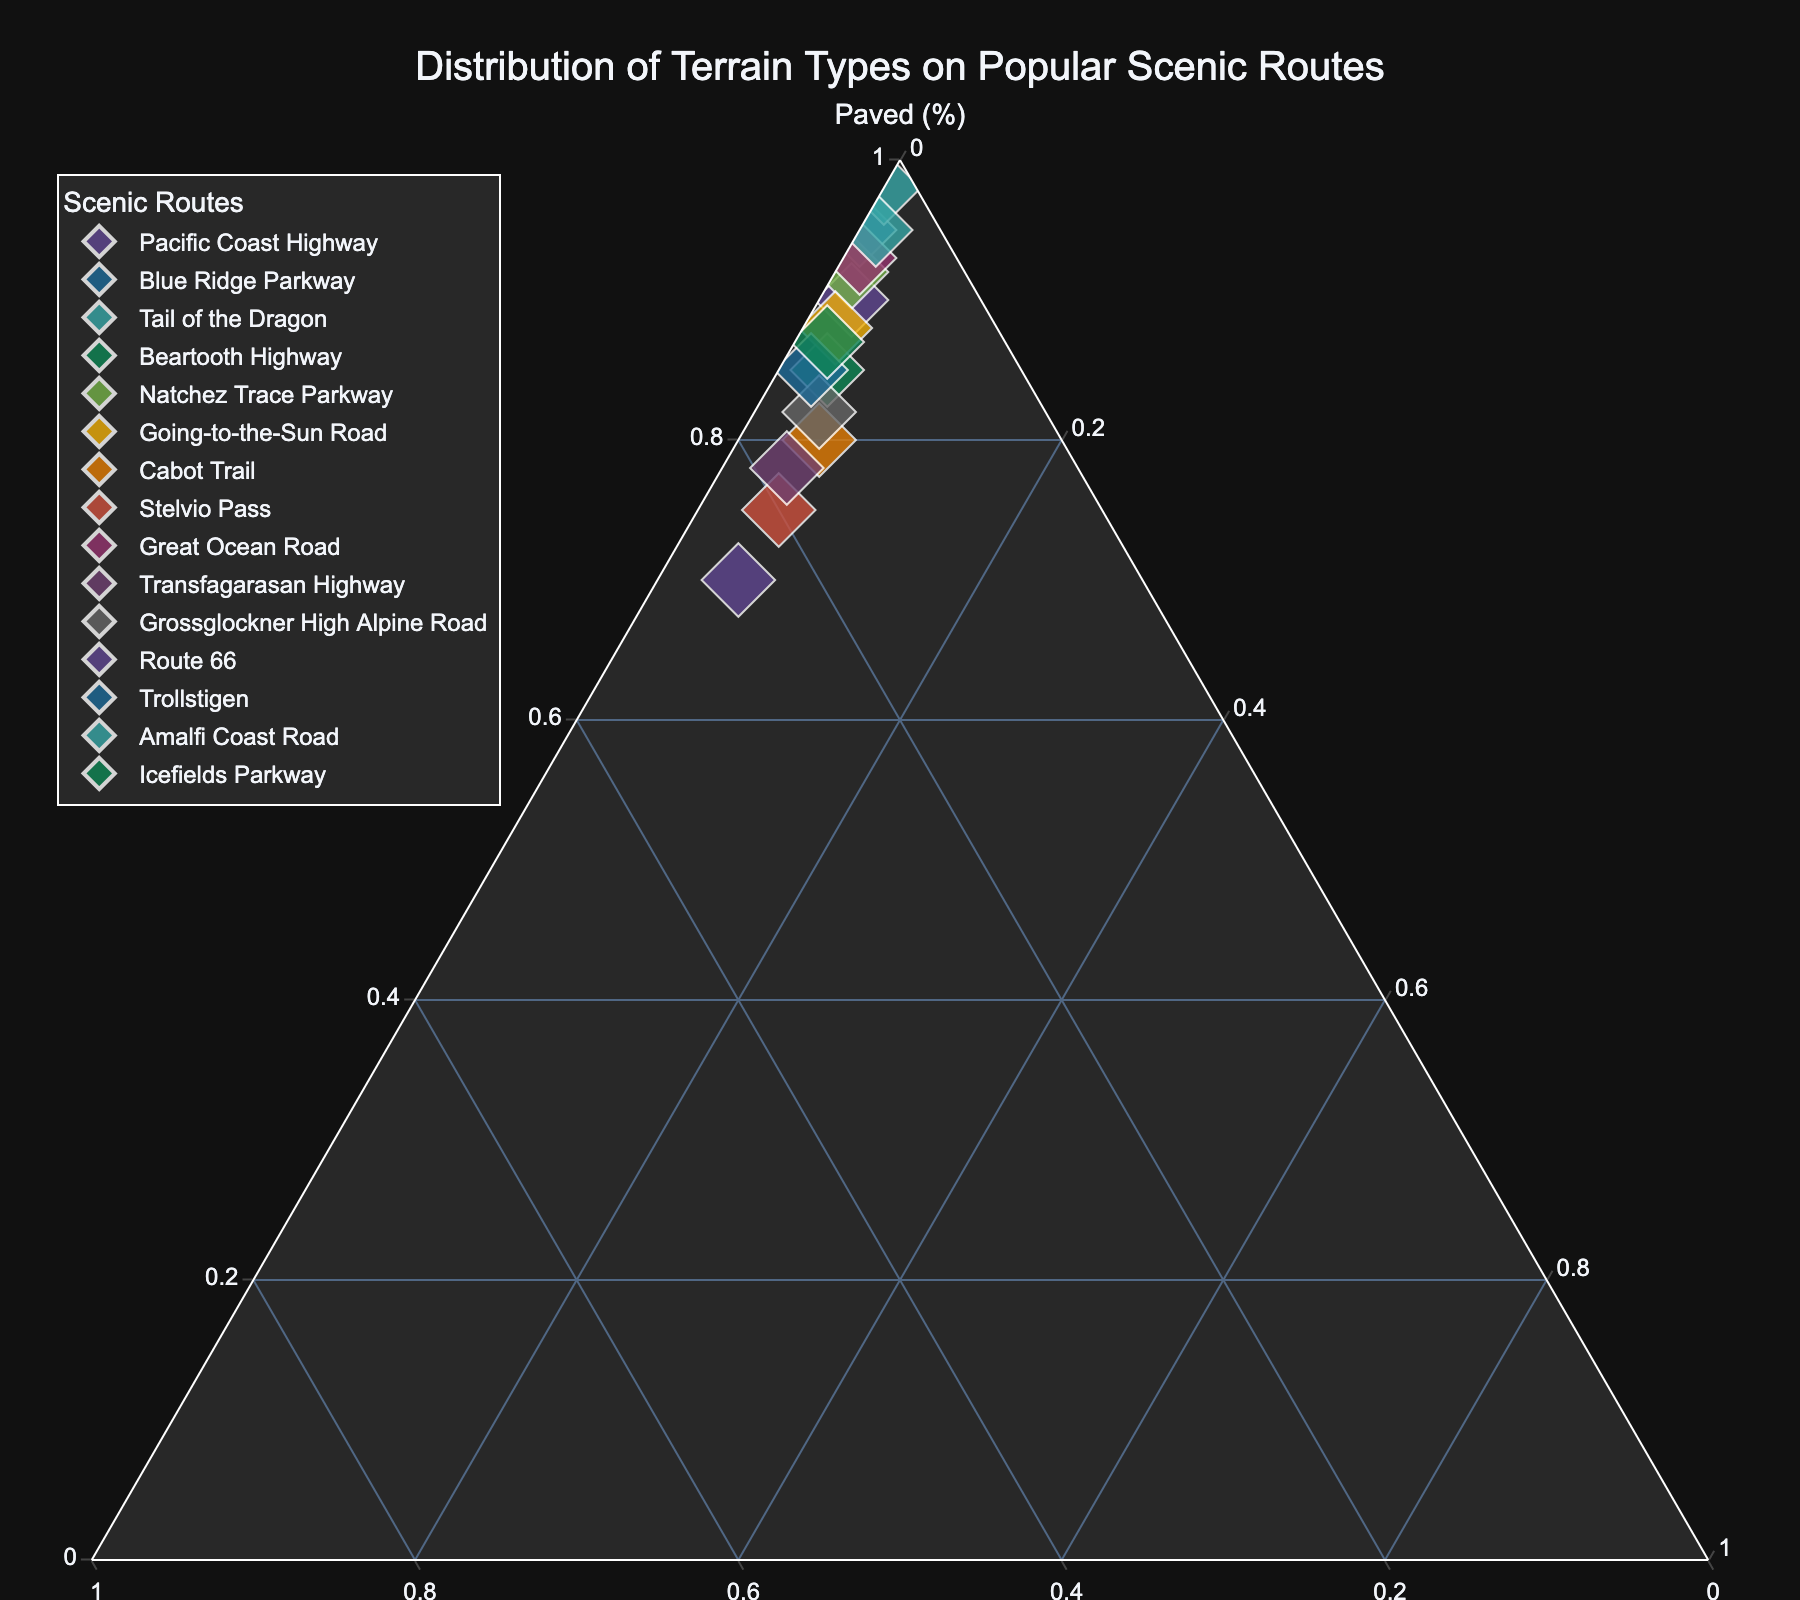What's the figure's title? The title is usually found at the top of the figure. It summarizes what the figure is about. In this case, it is "Distribution of Terrain Types on Popular Scenic Routes."
Answer: Distribution of Terrain Types on Popular Scenic Routes Which route has the highest proportion of paved roads? To find the route with the highest proportion of paved roads, look at the points closest to the "Paved (%)" vertex. The Tail of the Dragon is closest to this vertex with 98% paved roads.
Answer: Tail of the Dragon What are the terrain types for the Blue Ridge Parkway? Locate the Blue Ridge Parkway on the plot and read its corresponding values from the "Paved," "Gravel," and "Off-road" axes in the figure.
Answer: 95% Paved, 5% Gravel, 0% Off-road Which route has the most balanced distribution of terrain types? A balanced distribution will be closer to the center of the ternary plot, indicating more equal parts of the three terrains. The Cabot Trail appears relatively balanced with 80% Paved, 15% Gravel, and 5% Off-road.
Answer: Cabot Trail Is there any route with more than 20% gravel roads? Identify points close to the "Gravel (%)" vertex, which signifies higher gravel road percentages. Route 66 has 25% gravel roads.
Answer: Route 66 Compare the gravel roads percentages of the Beartooth Highway and the Transfagarasan Highway. Which is higher? Find and compare the positions of Beartooth Highway and Transfagarasan Highway on the "Gravel (%)" axis. Beartooth Highway has 12% gravel and Transfagarasan Highway has 18% gravel.
Answer: Transfagarasan Highway Which routes have exactly 2% off-road terrain? Identify points along the "Off-road (%)" axis at the 2% mark. The Pacific Coast Highway, Tail of the Dragon, Going-to-the-Sun Road, Icefields Parkway, and Trollstigen each have 2% off-road terrain.
Answer: Pacific Coast Highway, Tail of the Dragon, Going-to-the-Sun Road, Icefields Parkway, Trollstigen Among the listed routes, which ones have 0% off-road terrain? Locate points along the baseline of the "Off-road (%)" axis that are at zero. The Blue Ridge Parkway and Tail of the Dragon have 0% off-road terrain.
Answer: Blue Ridge Parkway, Tail of the Dragon What's the total percentage of gravel and off-road terrain for the Stelvio Pass? Add the percentages of gravel and off-road for the Stelvio Pass. Gravel is 20% and off-road is 5%, so the total is 20% + 5% = 25%.
Answer: 25% What route has the most paved roads among those with at least 5% off-road terrain? Identify routes with at least 5% off-road. Then among those, compare their "Paved (%)" values. Cabot Trail and Route 66 both have exactly 5% off-road. The Cabot Trail has 80% paved roads.
Answer: Cabot Trail 